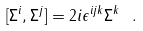<formula> <loc_0><loc_0><loc_500><loc_500>[ \Sigma ^ { i } , \Sigma ^ { j } ] = 2 i \epsilon ^ { i j k } \Sigma ^ { k } \ .</formula> 